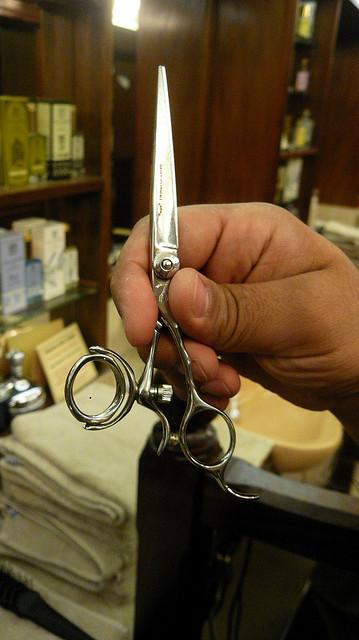How can you tell these are barber scissors?
Concise answer only. Handle. What is this person holding in  hand?
Be succinct. Scissors. What color are the scissors?
Short answer required. Silver. 